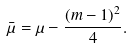<formula> <loc_0><loc_0><loc_500><loc_500>\bar { \mu } = \mu - \frac { ( m - 1 ) ^ { 2 } } 4 .</formula> 